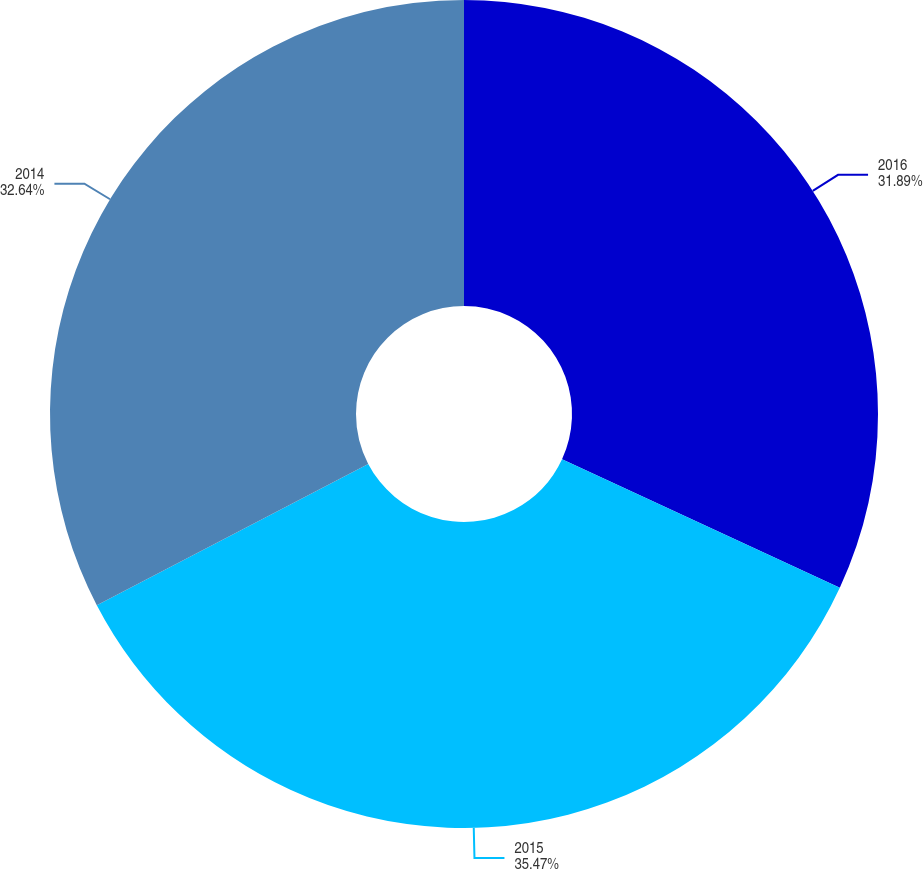Convert chart. <chart><loc_0><loc_0><loc_500><loc_500><pie_chart><fcel>2016<fcel>2015<fcel>2014<nl><fcel>31.89%<fcel>35.47%<fcel>32.64%<nl></chart> 